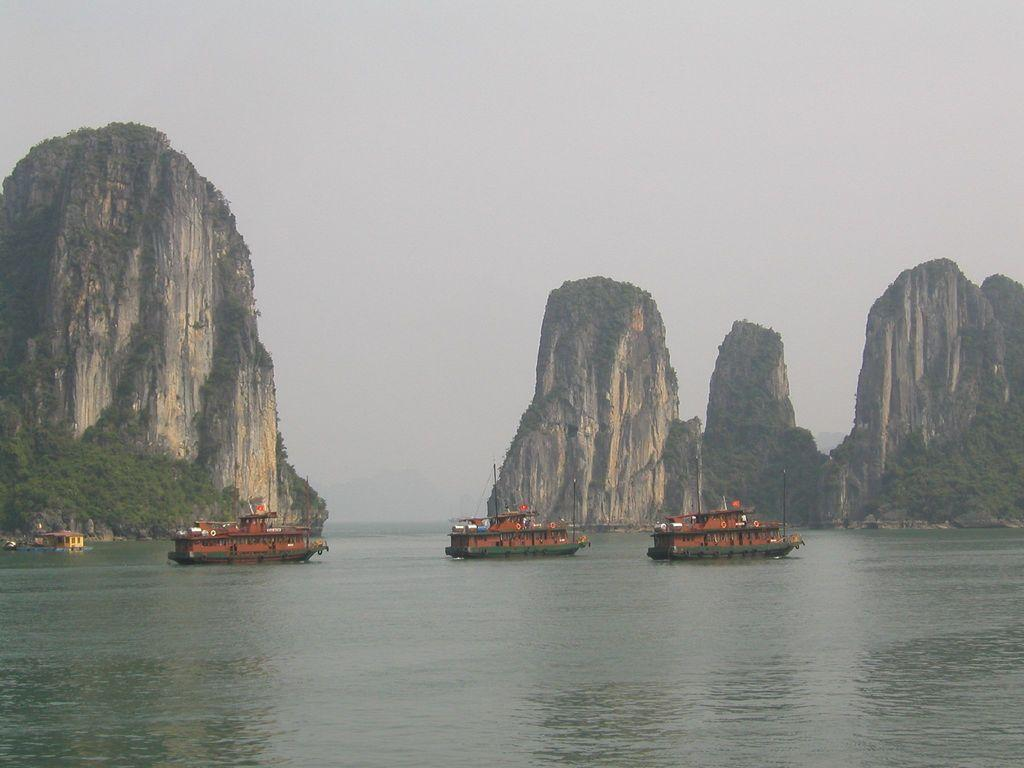What is on the water in the image? There are boats on the water in the image. What type of vegetation is present in the image? There are trees in the image. What geographical features can be seen in the image? There are hills in the image. What is visible in the background of the image? The sky is visible in the background of the image. Can you see any screws on the boats in the image? There are no screws visible on the boats in the image. What type of bubble is floating in the water in the image? There are no bubbles present in the image; it features boats on the water. 